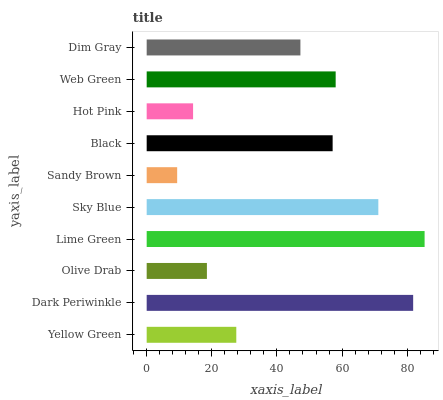Is Sandy Brown the minimum?
Answer yes or no. Yes. Is Lime Green the maximum?
Answer yes or no. Yes. Is Dark Periwinkle the minimum?
Answer yes or no. No. Is Dark Periwinkle the maximum?
Answer yes or no. No. Is Dark Periwinkle greater than Yellow Green?
Answer yes or no. Yes. Is Yellow Green less than Dark Periwinkle?
Answer yes or no. Yes. Is Yellow Green greater than Dark Periwinkle?
Answer yes or no. No. Is Dark Periwinkle less than Yellow Green?
Answer yes or no. No. Is Black the high median?
Answer yes or no. Yes. Is Dim Gray the low median?
Answer yes or no. Yes. Is Sandy Brown the high median?
Answer yes or no. No. Is Yellow Green the low median?
Answer yes or no. No. 